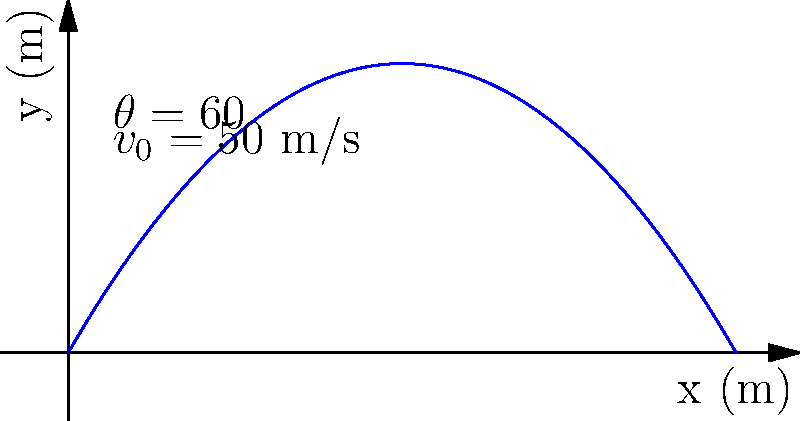A projectile is launched from ground level with an initial velocity of 50 m/s at an angle of 60° above the horizontal, as shown in the diagram. Assuming air resistance is negligible and using g = 9.8 m/s², calculate the maximum height reached by the projectile. To find the maximum height, we'll follow these steps:

1) The vertical component of the initial velocity is:
   $v_{0y} = v_0 \sin(\theta) = 50 \sin(60°) = 43.3$ m/s

2) The time to reach the maximum height is when the vertical velocity becomes zero:
   $v_y = v_{0y} - gt = 0$
   $t = \frac{v_{0y}}{g} = \frac{43.3}{9.8} = 4.42$ s

3) The maximum height can be calculated using the equation:
   $h = v_{0y}t - \frac{1}{2}gt^2$

4) Substituting the values:
   $h = 43.3 \cdot 4.42 - \frac{1}{2} \cdot 9.8 \cdot 4.42^2$
   $h = 191.39 - 95.7 = 95.69$ m

Therefore, the maximum height reached by the projectile is approximately 95.7 meters.
Answer: 95.7 m 